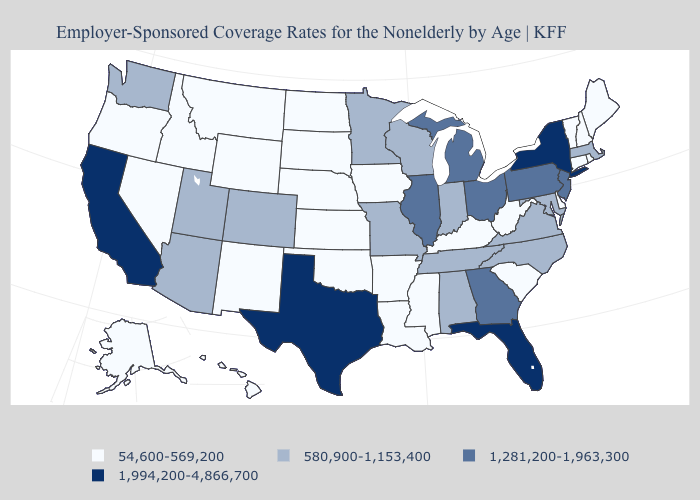What is the value of Oklahoma?
Answer briefly. 54,600-569,200. Does the first symbol in the legend represent the smallest category?
Quick response, please. Yes. Which states have the lowest value in the South?
Answer briefly. Arkansas, Delaware, Kentucky, Louisiana, Mississippi, Oklahoma, South Carolina, West Virginia. Which states have the highest value in the USA?
Give a very brief answer. California, Florida, New York, Texas. What is the lowest value in states that border Virginia?
Write a very short answer. 54,600-569,200. Name the states that have a value in the range 54,600-569,200?
Keep it brief. Alaska, Arkansas, Connecticut, Delaware, Hawaii, Idaho, Iowa, Kansas, Kentucky, Louisiana, Maine, Mississippi, Montana, Nebraska, Nevada, New Hampshire, New Mexico, North Dakota, Oklahoma, Oregon, Rhode Island, South Carolina, South Dakota, Vermont, West Virginia, Wyoming. What is the value of New Jersey?
Answer briefly. 1,281,200-1,963,300. What is the lowest value in the West?
Give a very brief answer. 54,600-569,200. Which states have the highest value in the USA?
Give a very brief answer. California, Florida, New York, Texas. Is the legend a continuous bar?
Answer briefly. No. Name the states that have a value in the range 1,281,200-1,963,300?
Short answer required. Georgia, Illinois, Michigan, New Jersey, Ohio, Pennsylvania. What is the value of Missouri?
Quick response, please. 580,900-1,153,400. Name the states that have a value in the range 1,994,200-4,866,700?
Write a very short answer. California, Florida, New York, Texas. Does the first symbol in the legend represent the smallest category?
Short answer required. Yes. Which states hav the highest value in the South?
Give a very brief answer. Florida, Texas. 